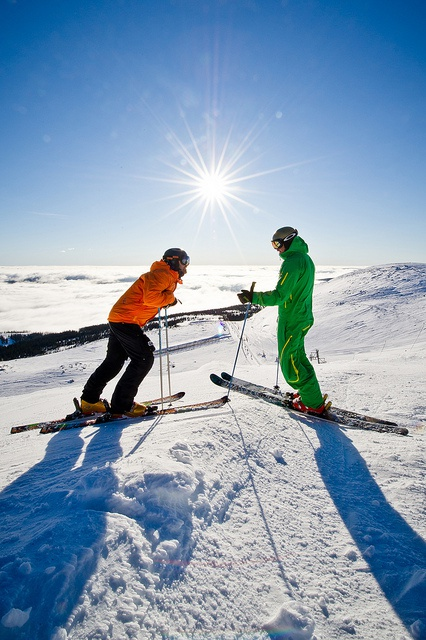Describe the objects in this image and their specific colors. I can see people in darkblue, black, brown, white, and red tones, people in darkblue, darkgreen, black, lightgray, and green tones, skis in darkblue, black, gray, darkgray, and lightgray tones, and skis in darkblue, black, lightgray, gray, and navy tones in this image. 